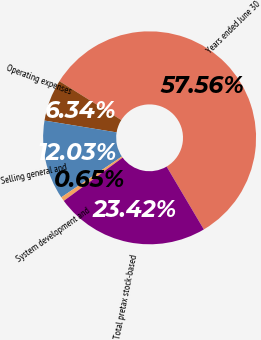<chart> <loc_0><loc_0><loc_500><loc_500><pie_chart><fcel>Years ended June 30<fcel>Operating expenses<fcel>Selling general and<fcel>System development and<fcel>Total pretax stock-based<nl><fcel>57.57%<fcel>6.34%<fcel>12.03%<fcel>0.65%<fcel>23.42%<nl></chart> 